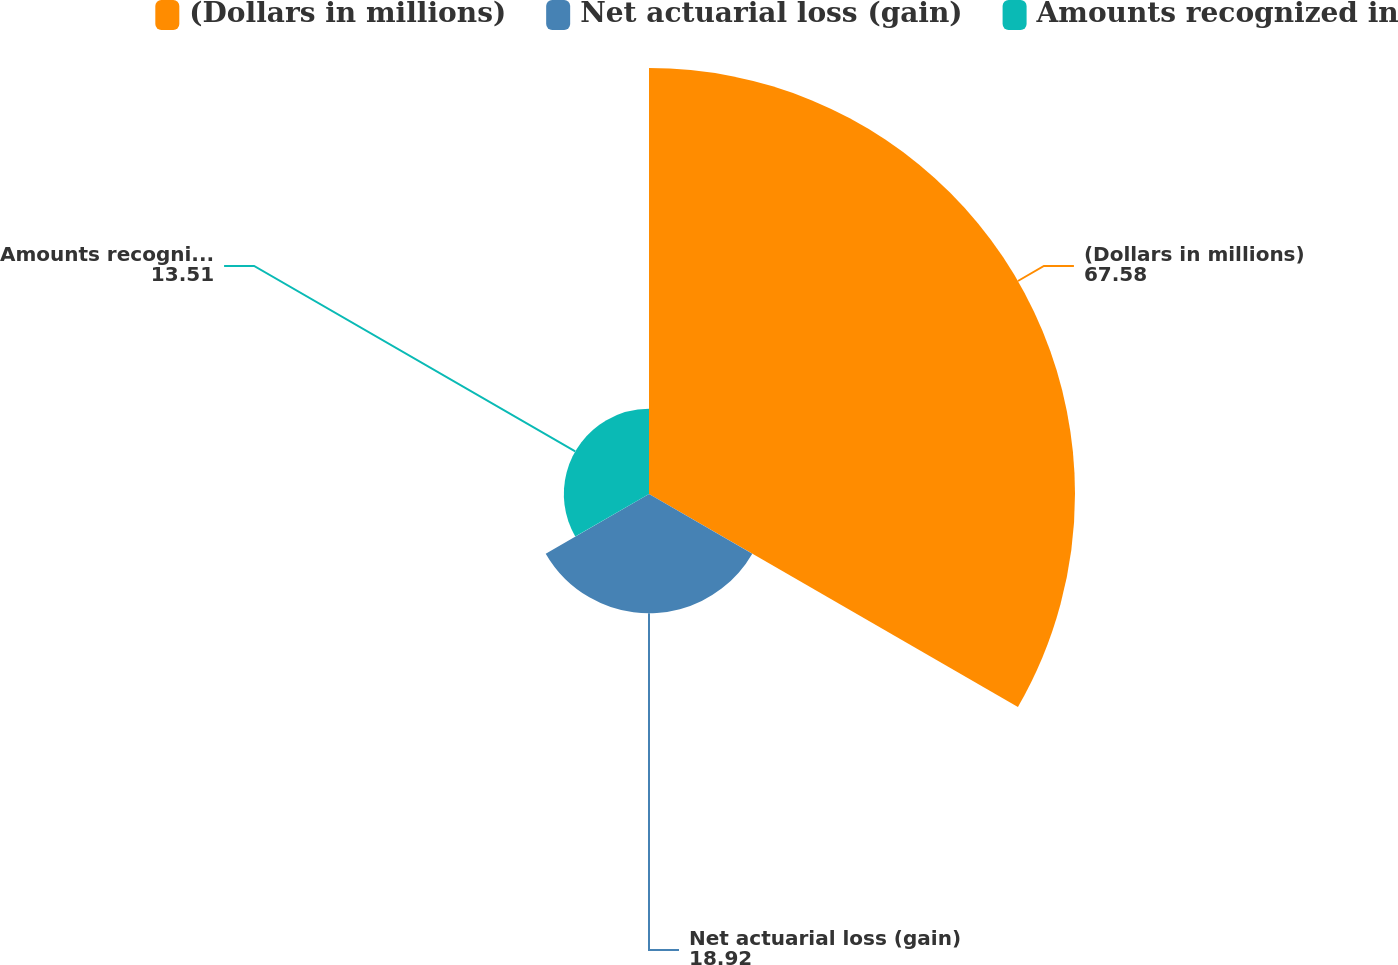Convert chart. <chart><loc_0><loc_0><loc_500><loc_500><pie_chart><fcel>(Dollars in millions)<fcel>Net actuarial loss (gain)<fcel>Amounts recognized in<nl><fcel>67.58%<fcel>18.92%<fcel>13.51%<nl></chart> 